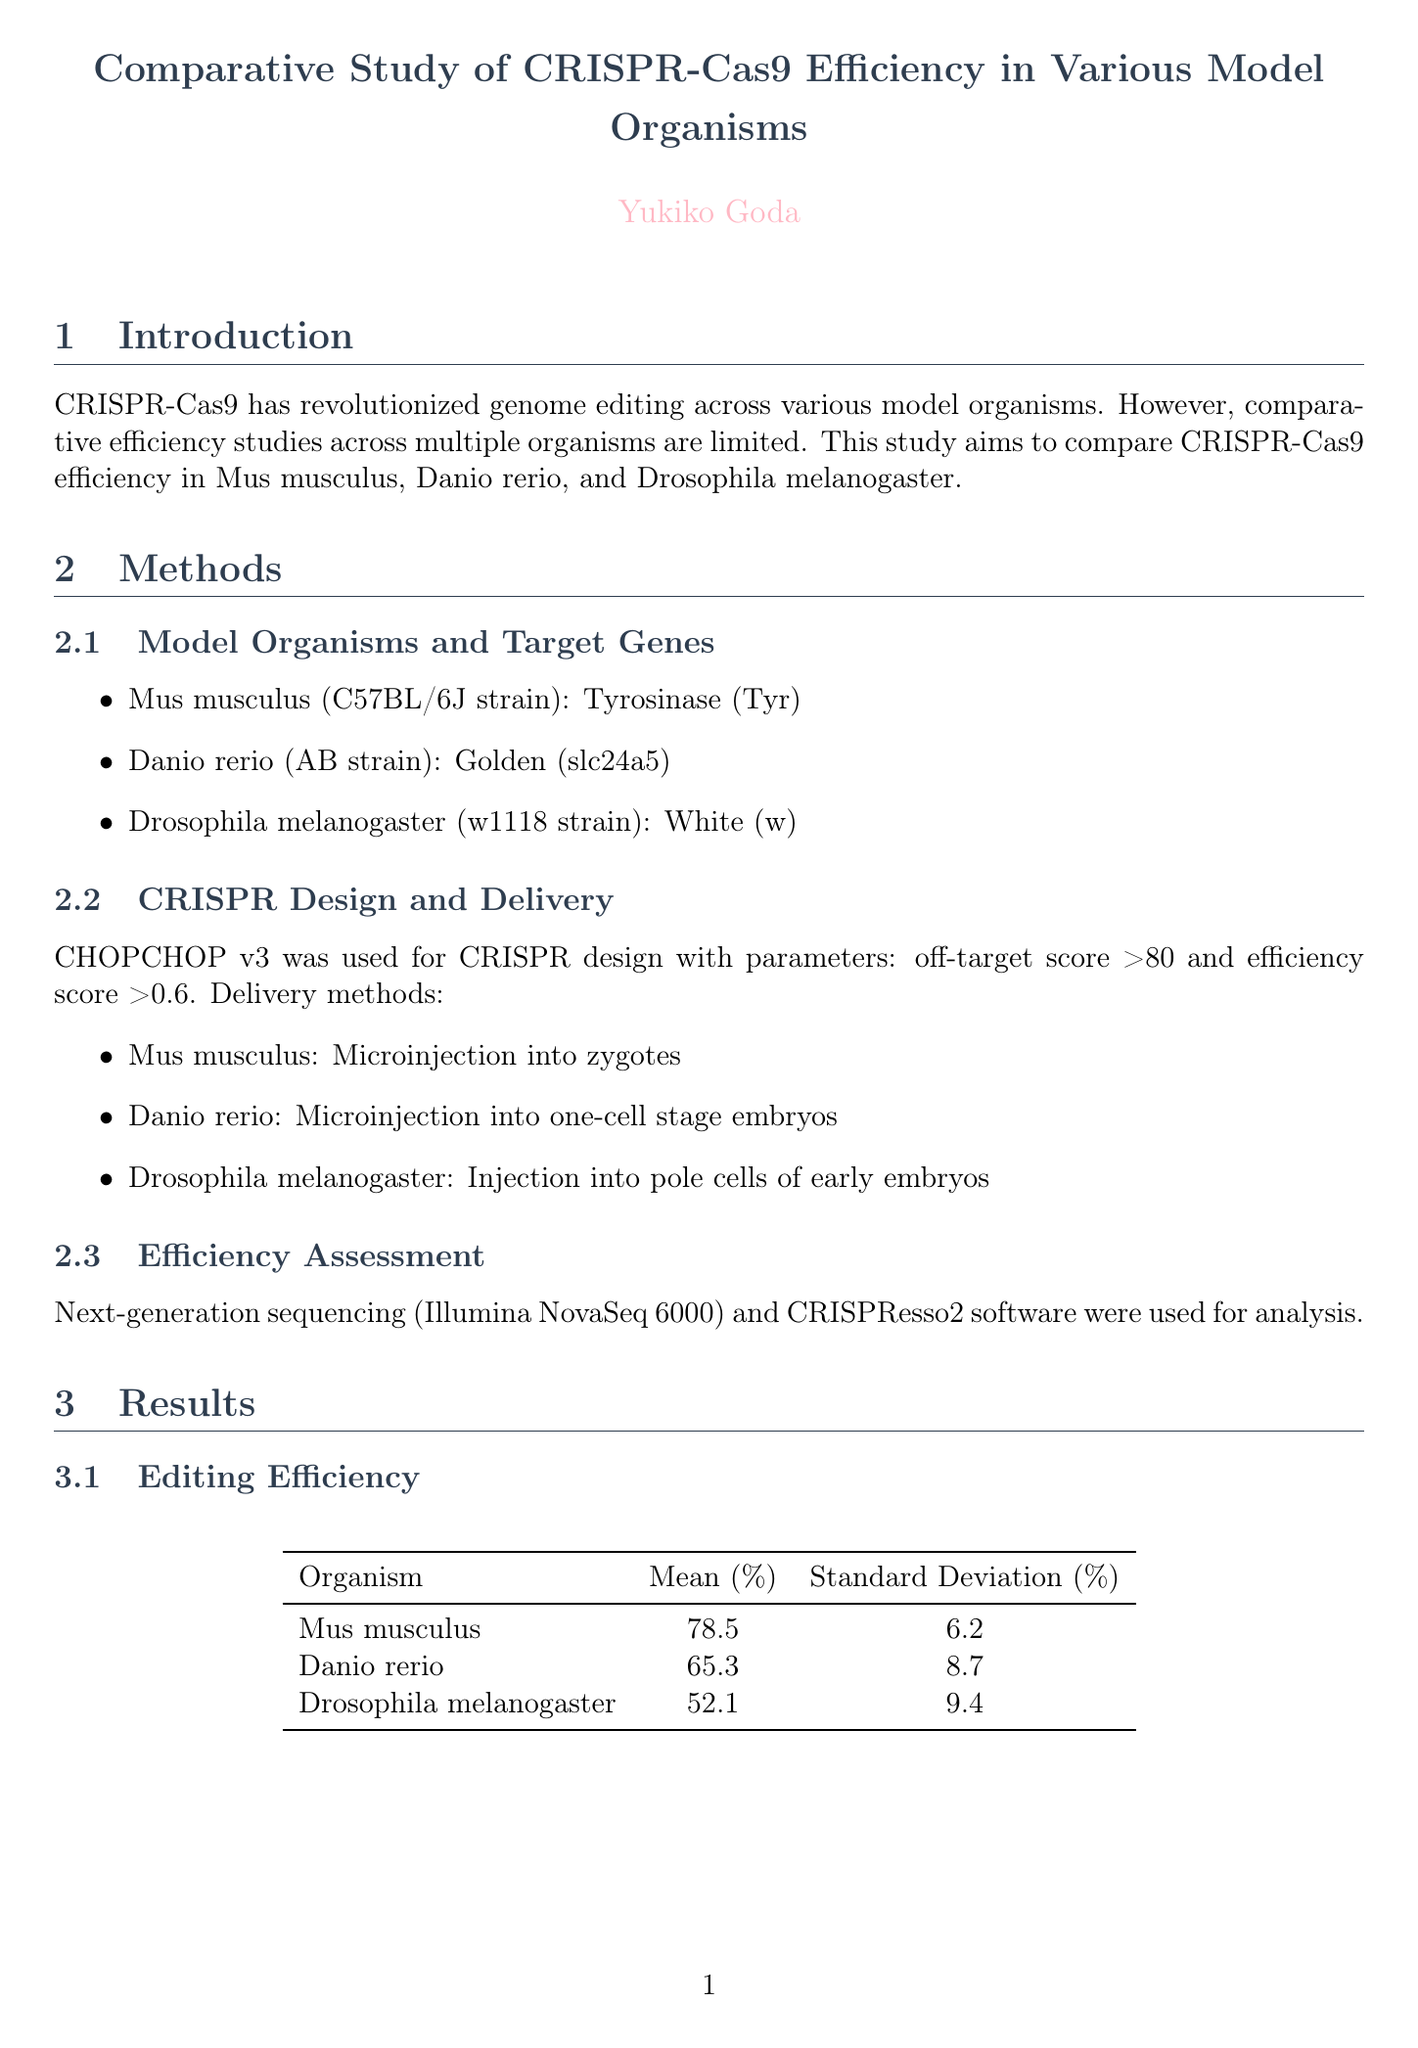What are the model organisms used in the study? The document specifies the model organisms studied: Mus musculus, Danio rerio, and Drosophila melanogaster.
Answer: Mus musculus, Danio rerio, Drosophila melanogaster What is the p-value from the statistical analysis? The p-value is reported from the one-way ANOVA test conducted in the study.
Answer: 0.0023 What is the mean editing efficiency for Mus musculus? The mean editing efficiency for Mus musculus is provided in the results section, showing the average success rate of CRISPR-Cas9.
Answer: 78.5 Which tool was used for CRISPR design? The document mentions a specific tool used for designing CRISPR sequences, which is key to the methodology.
Answer: CHOPCHOP v3 What optimization strategy involves temperature modulation for Mus musculus? The strategy to optimize genome editing for Mus musculus includes specific incubation temperatures, which is detailed in the optimization section.
Answer: 37°C Which model organism showed the lowest editing efficiency? The document includes a comparison of editing efficiencies across organisms, highlighting which had the least success.
Answer: Drosophila melanogaster What statistical test was used to compare editing efficiencies? The type of statistical analysis performed is noted, indicating how the researchers assessed differences among the organisms.
Answer: One-way ANOVA What is the expected improvement from using DeepSpCas9 for sgRNA design? The expected improvement is expressed in percentage increase and is mentioned in the optimization strategies section of the document.
Answer: 15-20% What are the target genes for Danio rerio? The specific gene targeted in Danio rerio is listed in the methods section, providing insight into the genetic focus of the study.
Answer: Golden (slc24a5) 